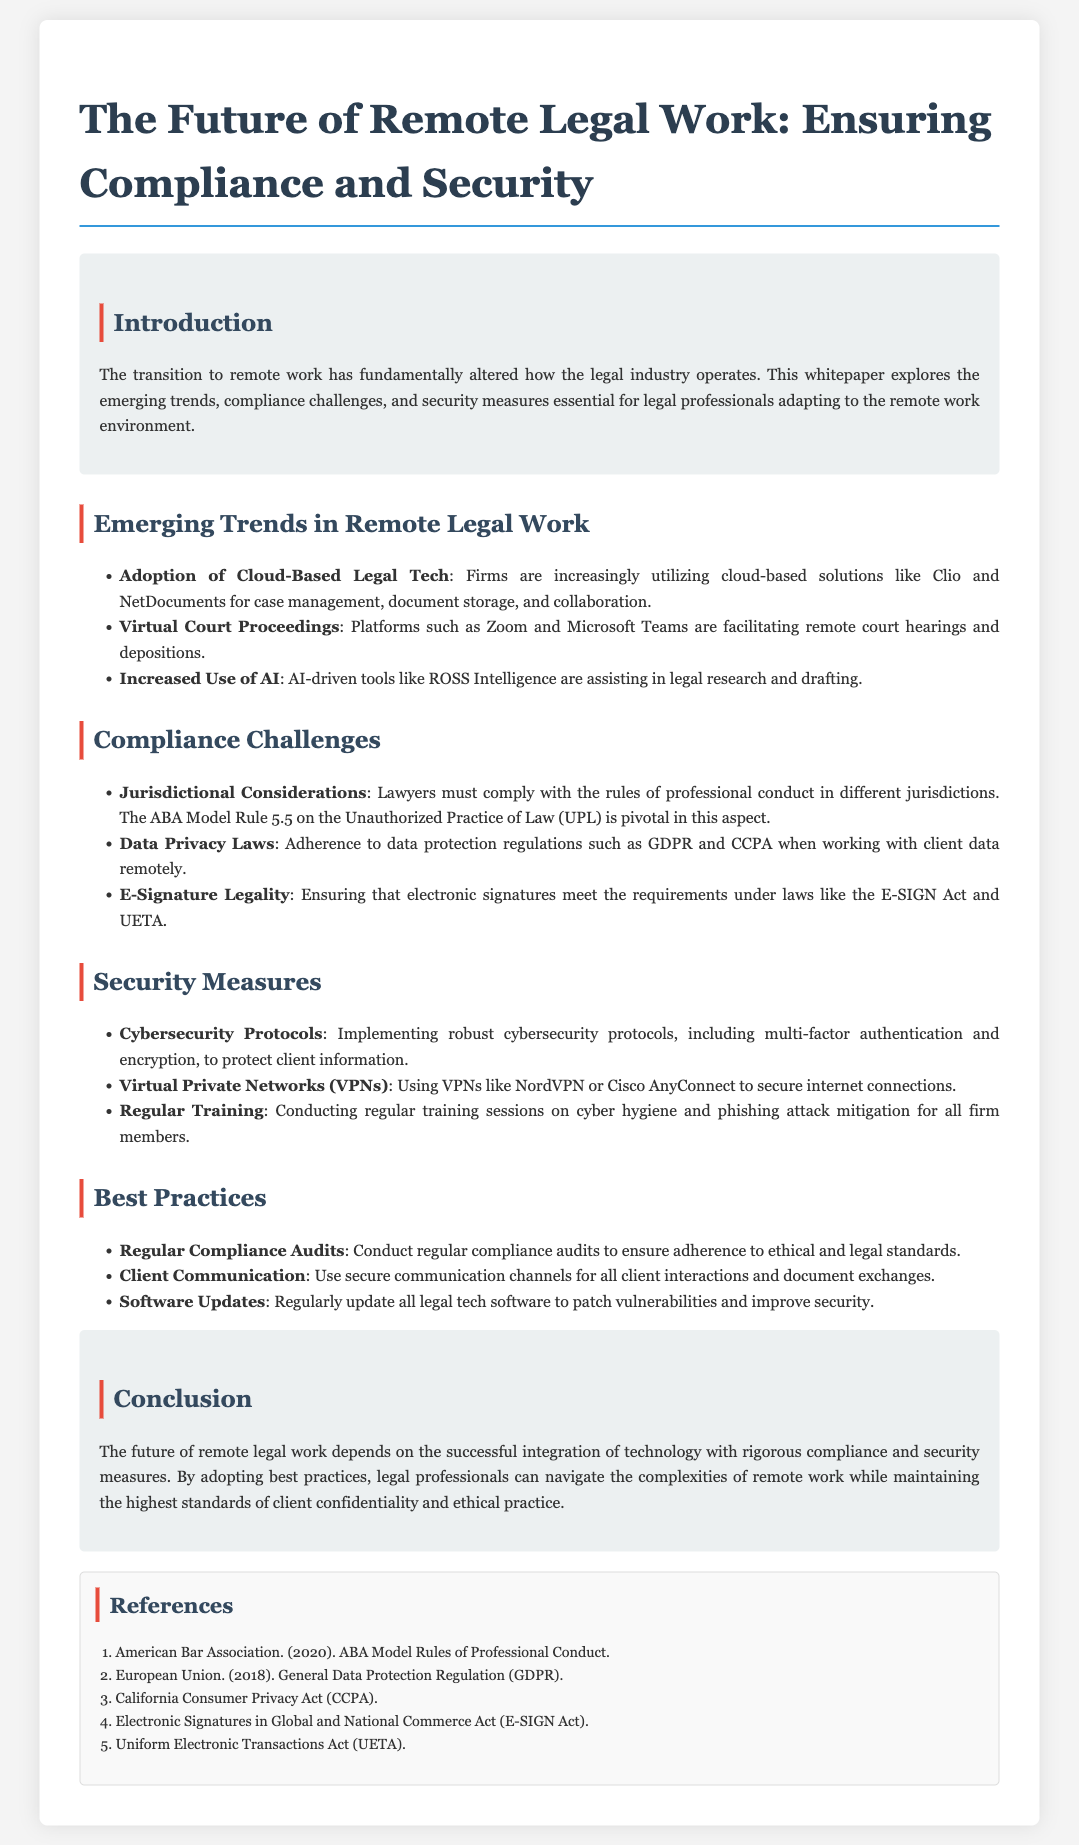What are the primary tools used for remote legal work? The document lists specific tools adopted by legal professionals for remote work, such as Clio, NetDocuments, Zoom, and Microsoft Teams.
Answer: Clio and NetDocuments What major data protection regulations must lawyers comply with? The compliance challenges section mentions GDPR and CCPA as essential data privacy laws for legal professionals.
Answer: GDPR and CCPA What is the focus of the section titled "Compliance Challenges"? This section addresses various compliance aspects that legal professionals must navigate when working remotely, including jurisdictional considerations and data privacy laws.
Answer: Jurisdictional considerations and data privacy laws What cybersecurity measure involves securing internet connections? The document specifies using Virtual Private Networks (VPNs) as a security measure to secure internet connections.
Answer: Virtual Private Networks (VPNs) How often should legal firms conduct compliance audits? The best practices section highlights that regular compliance audits are necessary for ensuring adherence to ethical and legal standards.
Answer: Regularly What role does AI play in remote legal work? The document mentions that AI-driven tools assist in legal research and drafting, demonstrating their importance in the remote legal environment.
Answer: Assisting in legal research and drafting What is the objective of the whitepaper? The whitepaper aims to explore trends, compliance challenges, and security measures essential for legal professionals adapting to remote work.
Answer: Explore trends, compliance challenges, and security measures What should legal professionals use for secure client communication? The "Best Practices" section advises using secure communication channels for all client interactions and document exchanges.
Answer: Secure communication channels Which act regulates electronic signatures in the document? The document refers specifically to the E-SIGN Act in relation to the legality of electronic signatures.
Answer: E-SIGN Act 